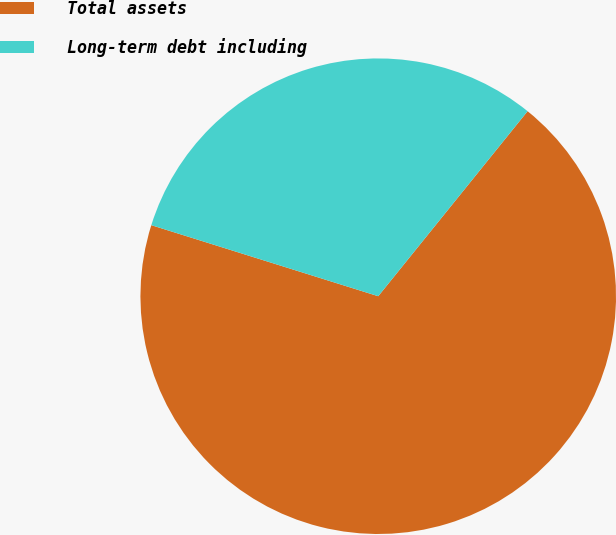<chart> <loc_0><loc_0><loc_500><loc_500><pie_chart><fcel>Total assets<fcel>Long-term debt including<nl><fcel>69.02%<fcel>30.98%<nl></chart> 